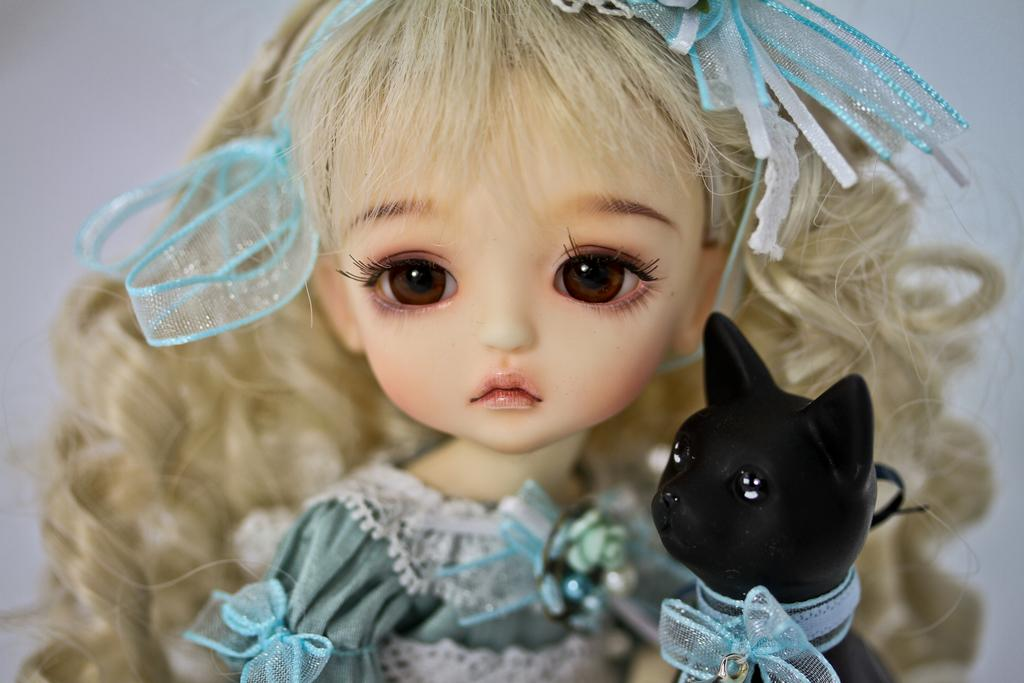What is the main subject in the image? There is a doll in the image. What can be observed about the doll's appearance? The doll is wearing clothes and has a hair band. What other toy is present in the image? There is a toy cat in the image. What is the color of the toy cat? The toy cat is black in color. How would you describe the background of the image? The background of the image is white and slightly blurred. Is the doll experiencing any pain in the image? There is no indication of pain in the image; the doll is simply a toy. What type of milk is being served in the image? There is no milk present in the image. 